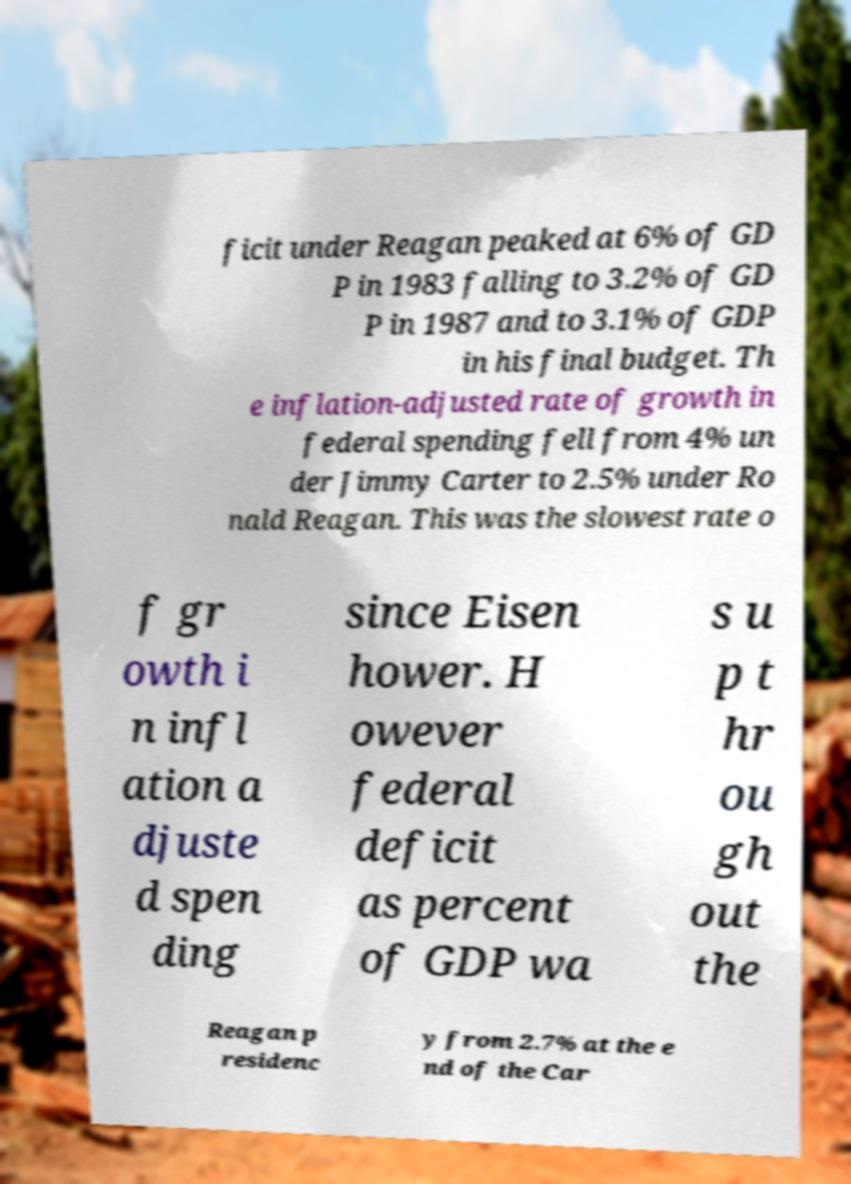Could you extract and type out the text from this image? ficit under Reagan peaked at 6% of GD P in 1983 falling to 3.2% of GD P in 1987 and to 3.1% of GDP in his final budget. Th e inflation-adjusted rate of growth in federal spending fell from 4% un der Jimmy Carter to 2.5% under Ro nald Reagan. This was the slowest rate o f gr owth i n infl ation a djuste d spen ding since Eisen hower. H owever federal deficit as percent of GDP wa s u p t hr ou gh out the Reagan p residenc y from 2.7% at the e nd of the Car 